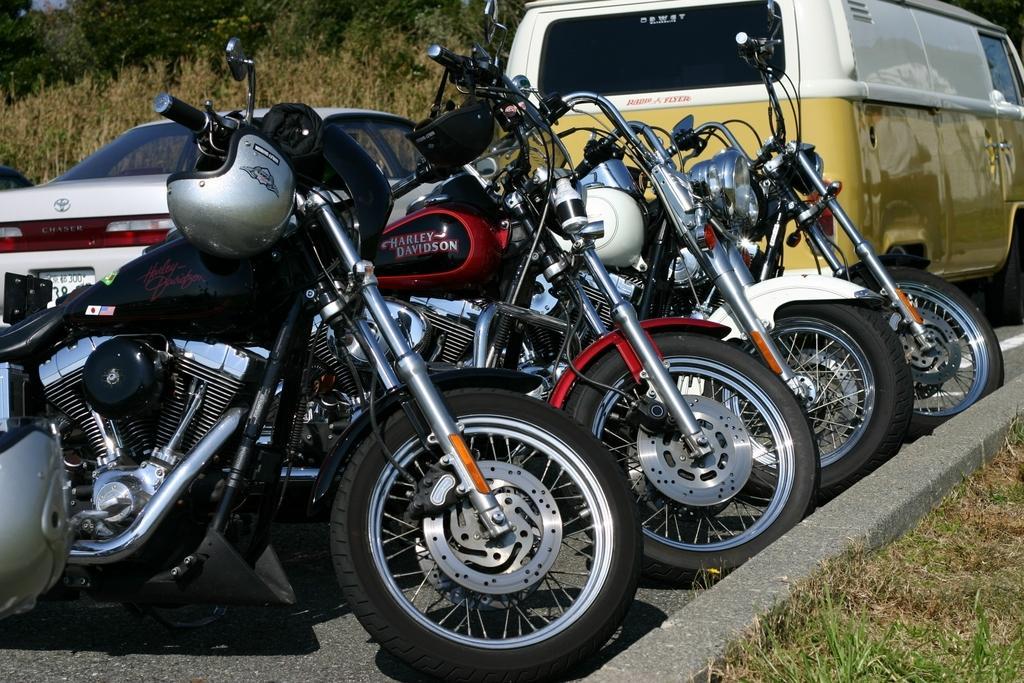Can you describe this image briefly? There are bikes and vehicles on the road. This is grass. In the background there are trees. 